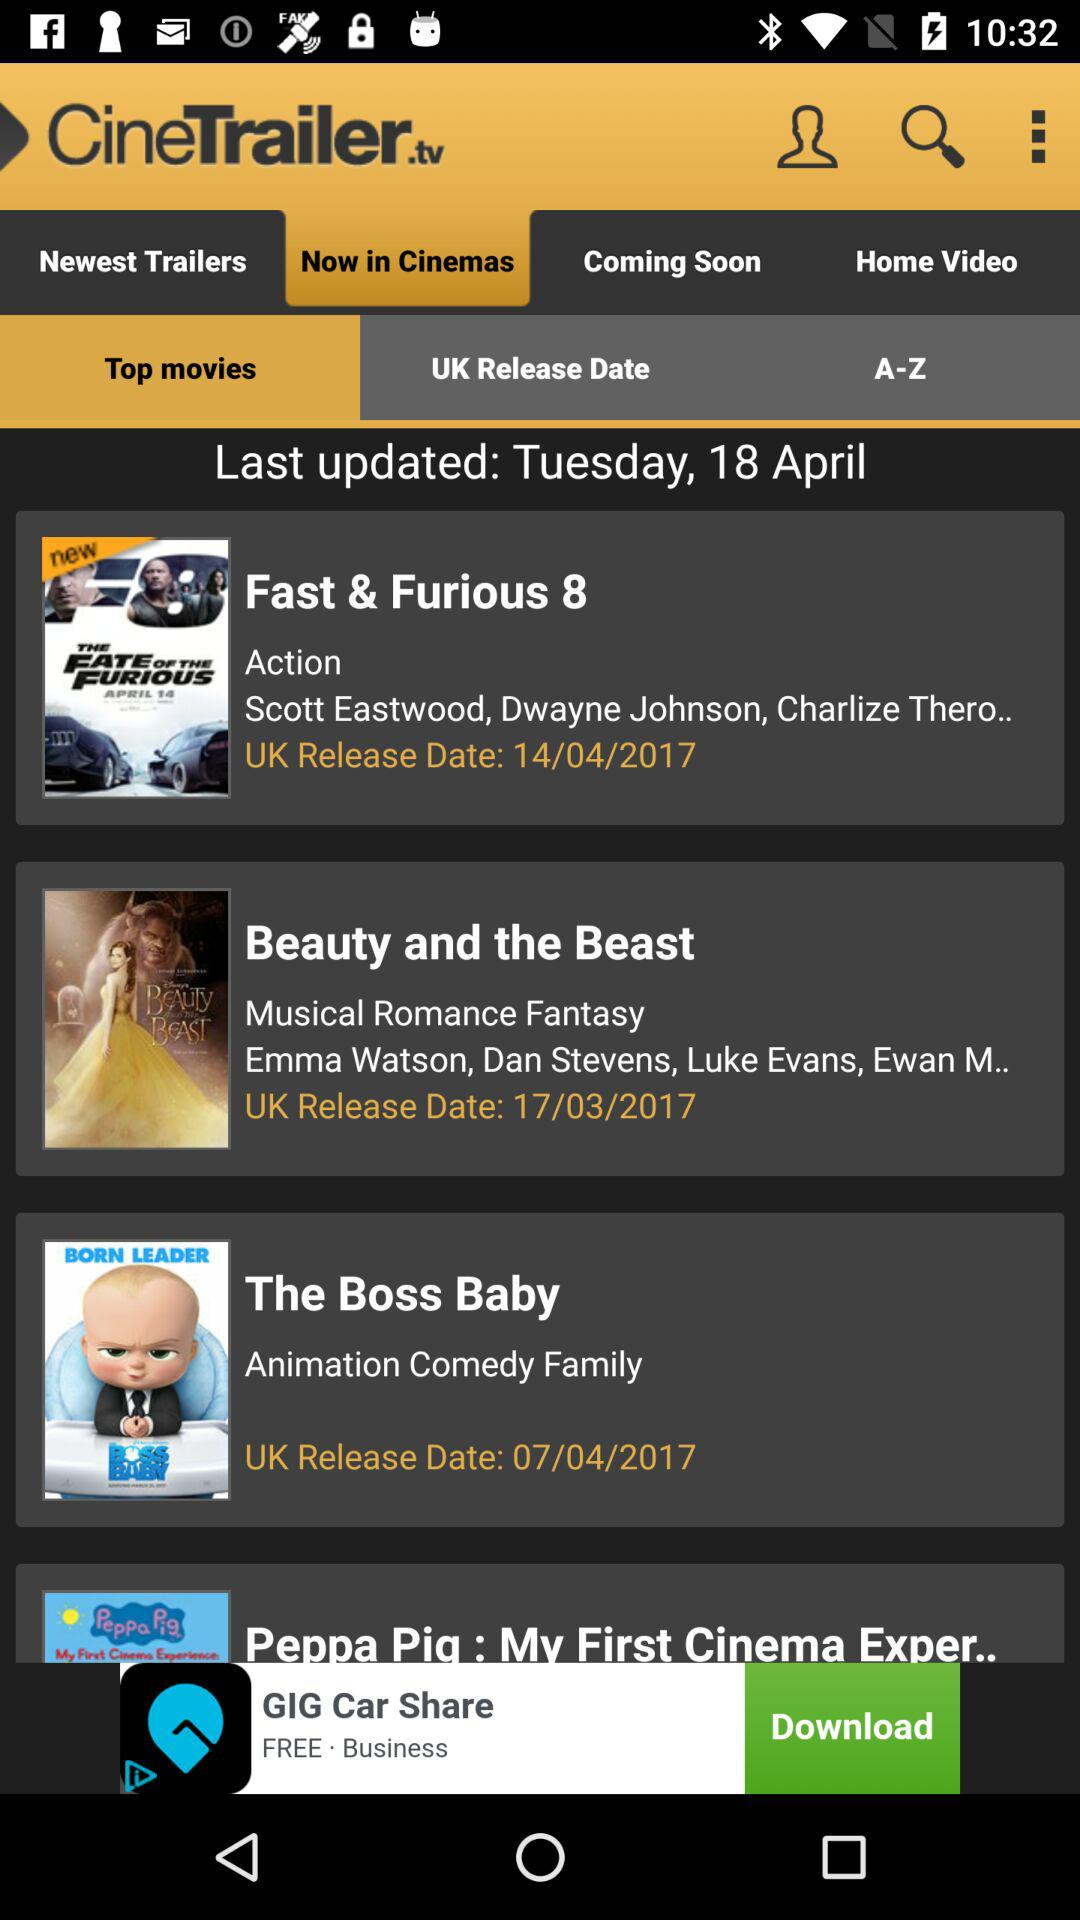What is the name of the application? The name of the application is "CineTrailer". 